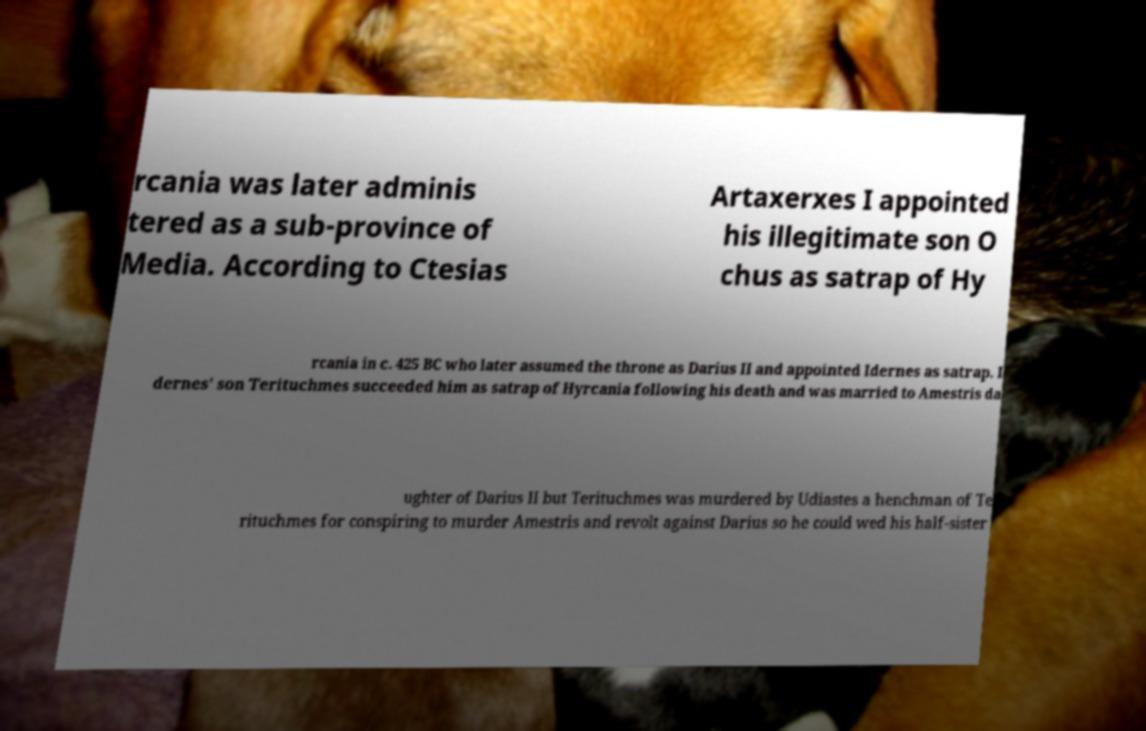Please identify and transcribe the text found in this image. rcania was later adminis tered as a sub-province of Media. According to Ctesias Artaxerxes I appointed his illegitimate son O chus as satrap of Hy rcania in c. 425 BC who later assumed the throne as Darius II and appointed Idernes as satrap. I dernes' son Terituchmes succeeded him as satrap of Hyrcania following his death and was married to Amestris da ughter of Darius II but Terituchmes was murdered by Udiastes a henchman of Te rituchmes for conspiring to murder Amestris and revolt against Darius so he could wed his half-sister 